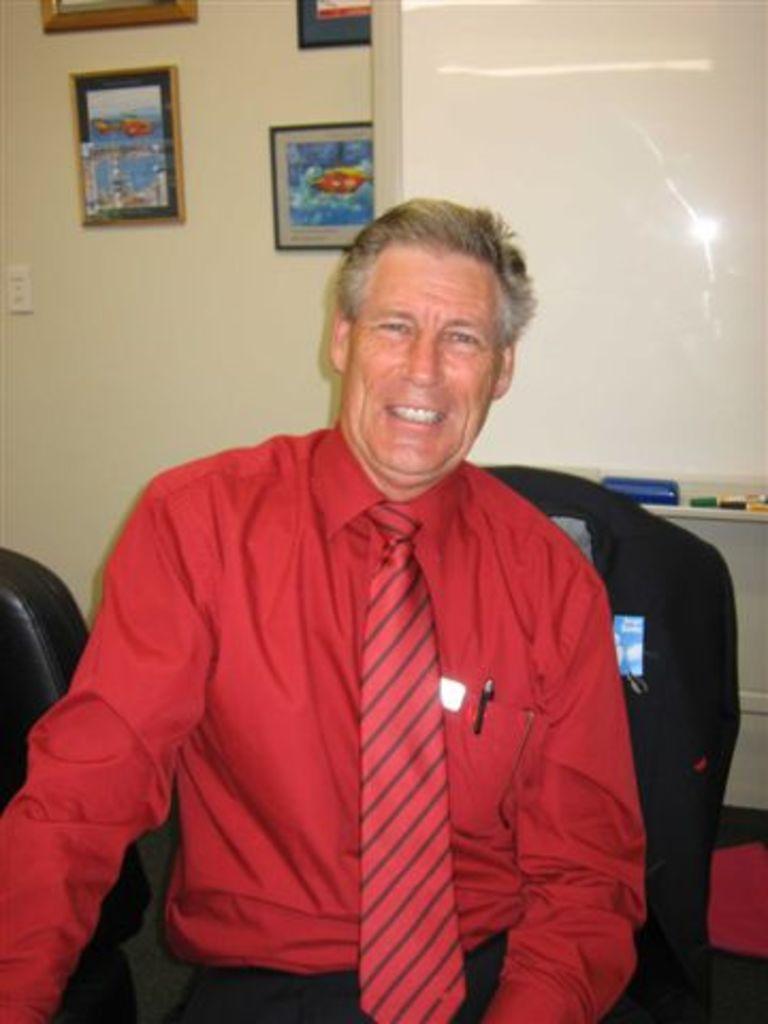Please provide a concise description of this image. In this image I can see a person and there are some frames attached to the wall. 